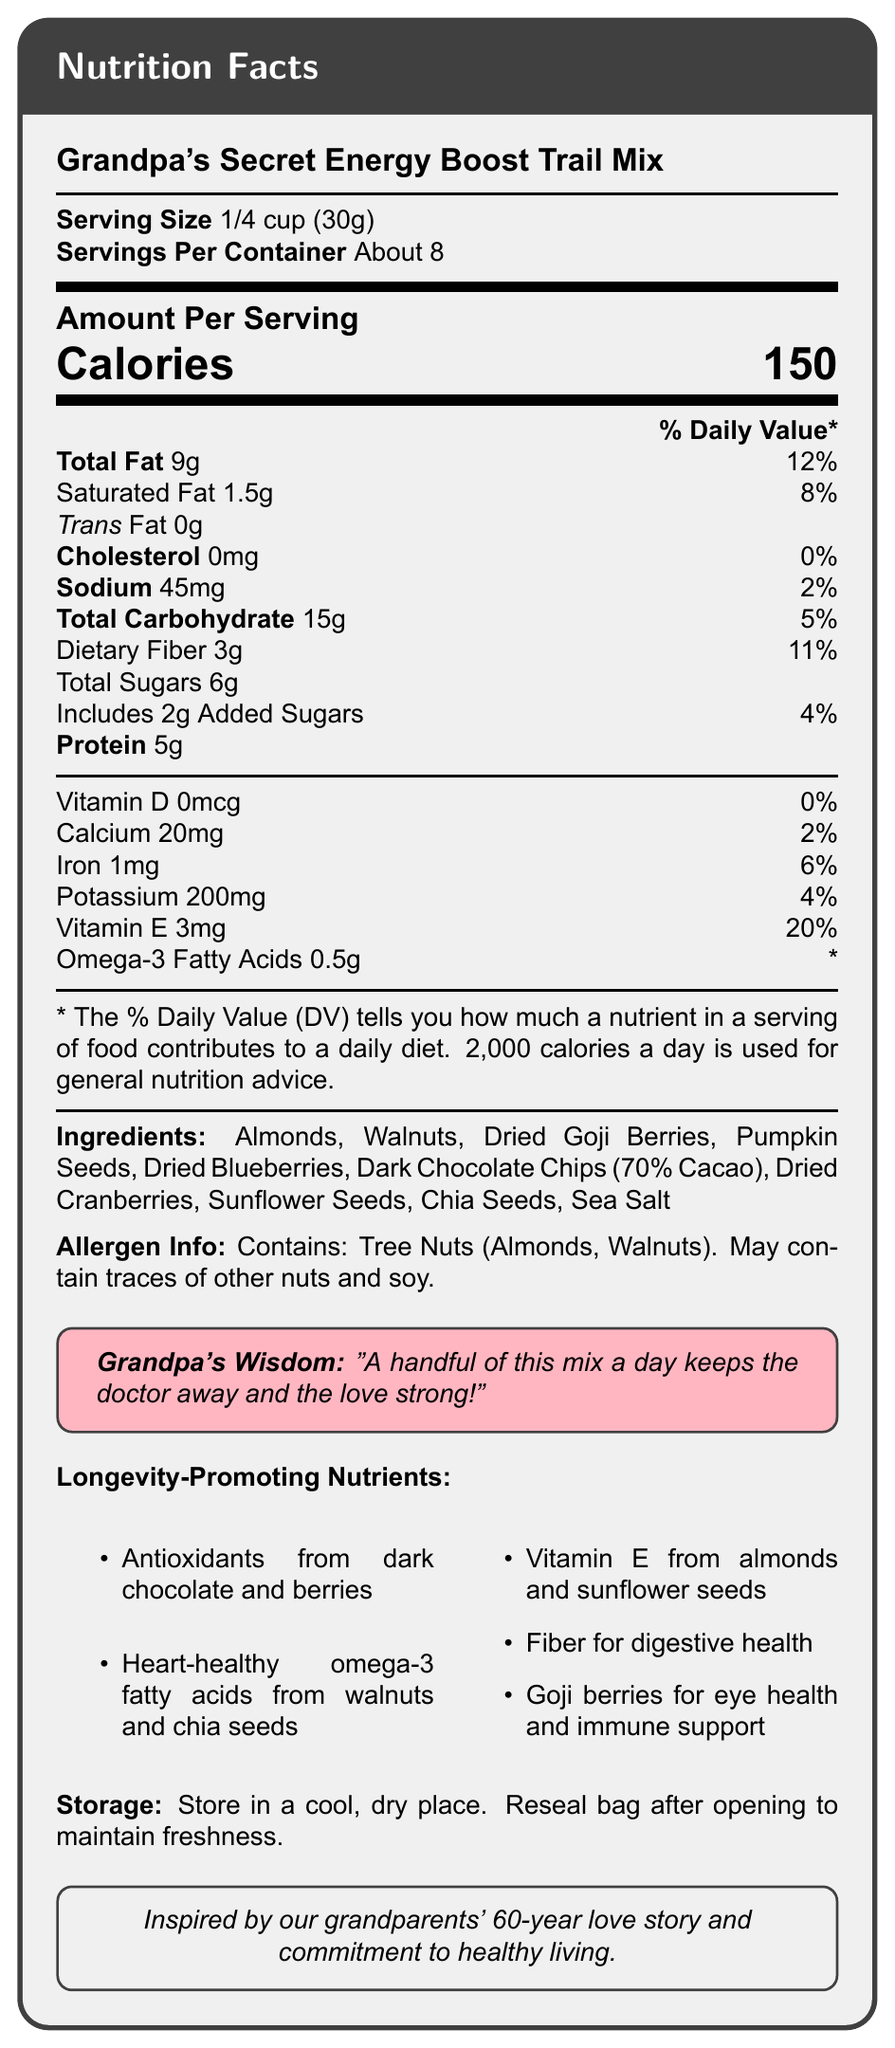who produces Grandpa's Secret Energy Boost Trail Mix? The document does not explicitly state who produces Grandpa's Secret Energy Boost Trail Mix. Therefore, the answer cannot be determined.
Answer: Cannot be determined what is the serving size? The serving size is clearly listed at the beginning of the document as "1/4 cup (30g)."
Answer: 1/4 cup (30g) how many servings are there per container? The document specifies that there are "About 8" servings per container.
Answer: About 8 how many calories are in one serving? The document states that one serving contains 150 calories.
Answer: 150 how much total fat is in one serving? The document indicates that each serving has 9 grams of total fat.
Answer: 9g what allergens are present in the trail mix? The allergen information section states that the mix contains Tree Nuts (Almonds, Walnuts) and may contain traces of other nuts and soy.
Answer: Tree Nuts (Almonds, Walnuts). May contain traces of other nuts and soy. which vitamins and minerals are specifically listed in the nutrition facts? The document lists Vitamin D, Calcium, Iron, Potassium, and Vitamin E with their amounts per serving and daily values.
Answer: Vitamin D, Calcium, Iron, Potassium, Vitamin E what percentage of the daily value of saturated fat does one serving provide? The document states that one serving provides 8% of the daily value of saturated fat.
Answer: 8% what ingredients are included in Grandpa's Secret Energy Boost Trail Mix? The ingredients are clearly listed towards the end of the document.
Answer: Almonds, Walnuts, Dried Goji Berries, Pumpkin Seeds, Dried Blueberries, Dark Chocolate Chips (70% Cacao), Dried Cranberries, Sunflower Seeds, Chia Seeds, Sea Salt how much protein is in a serving? The document states that each serving contains 5 grams of protein.
Answer: 5g which of the following is a longevity-promoting nutrient found in Grandpa's Secret Energy Boost Trail Mix? A. Vitamin C from oranges B. Omega-3 fatty acids from walnuts C. Vitamin K from kale D. Zinc from nuts Omega-3 fatty acids from walnuts is listed as one of the longevity-promoting nutrients in the document.
Answer: B what is the % daily value of fiber in one serving? A. 2% B. 4% C. 11% D. 20% The document lists the daily value of dietary fiber as 11%.
Answer: C is there any cholesterol in Grandpa's Secret Energy Boost Trail Mix? The document specifies that there is 0mg of cholesterol per serving.
Answer: No what is the main idea of the document? The document gives a comprehensive overview of the nutritional content, ingredients, and health benefits of the trail mix, including a note on the inspiration from grandparents' love story and lifestyle advice from Grandpa.
Answer: The main idea of the document is to provide the nutritional information, ingredient list, allergens, and health benefits of Grandpa's Secret Energy Boost Trail Mix, which includes details like serving size, calories, and longevity-promoting nutrients. how much vitamin D is in a serving? The document specifies that there is 0mcg of vitamin D in one serving.
Answer: 0mcg what does Grandpa's wisdom related to the trail mix suggest? The document includes a tcolorbox with Grandpa's wisdom: "A handful of this mix a day keeps the doctor away and the love strong!"
Answer: "A handful of this mix a day keeps the doctor away and the love strong!" do the trail mix contain added sugars? The document specifies that there are 2g of added sugars in one serving of the trail mix.
Answer: Yes how should the trail mix be stored? The storage instructions indicate that the trail mix should be stored in a cool, dry place, and the bag should be resealed after opening to maintain freshness.
Answer: In a cool, dry place. Reseal bag after opening to maintain freshness. 